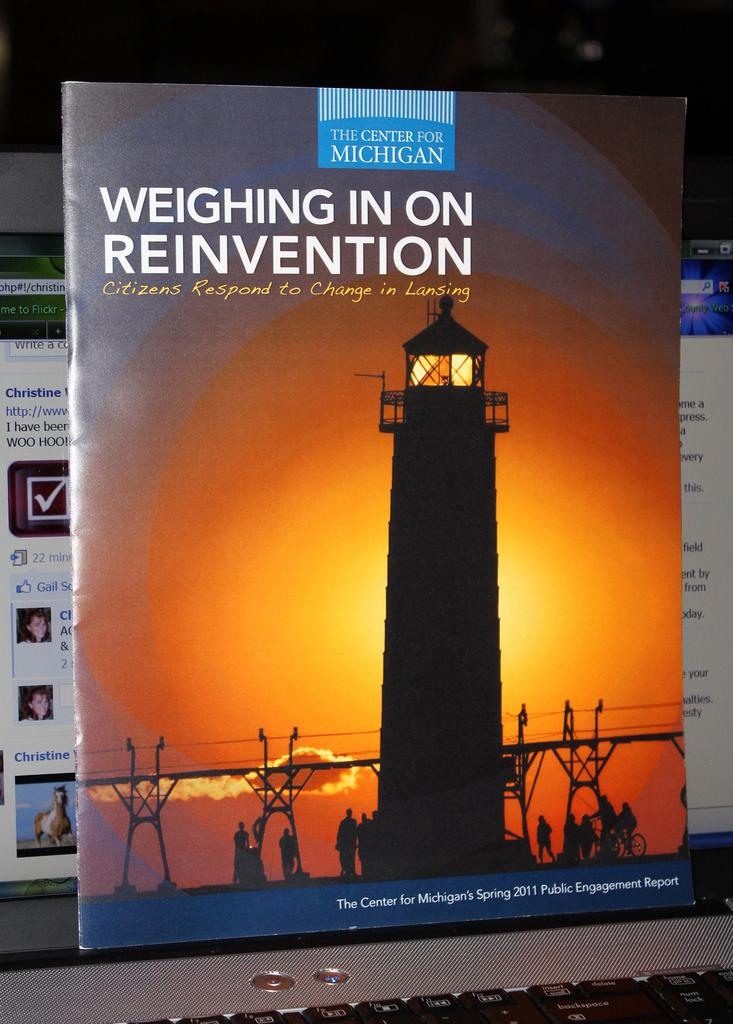<image>
Describe the image concisely. A book from the Center for Michigan is labeled Spring 2011. 